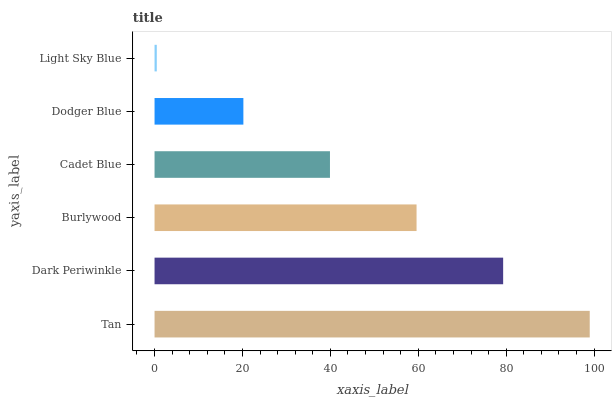Is Light Sky Blue the minimum?
Answer yes or no. Yes. Is Tan the maximum?
Answer yes or no. Yes. Is Dark Periwinkle the minimum?
Answer yes or no. No. Is Dark Periwinkle the maximum?
Answer yes or no. No. Is Tan greater than Dark Periwinkle?
Answer yes or no. Yes. Is Dark Periwinkle less than Tan?
Answer yes or no. Yes. Is Dark Periwinkle greater than Tan?
Answer yes or no. No. Is Tan less than Dark Periwinkle?
Answer yes or no. No. Is Burlywood the high median?
Answer yes or no. Yes. Is Cadet Blue the low median?
Answer yes or no. Yes. Is Light Sky Blue the high median?
Answer yes or no. No. Is Dark Periwinkle the low median?
Answer yes or no. No. 